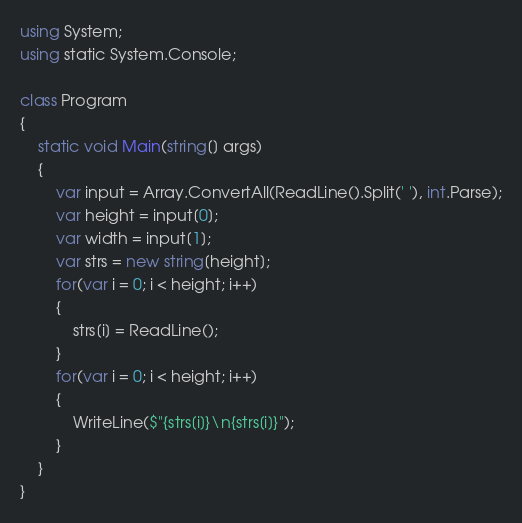Convert code to text. <code><loc_0><loc_0><loc_500><loc_500><_C#_>using System;
using static System.Console;

class Program
{
    static void Main(string[] args)
    {
        var input = Array.ConvertAll(ReadLine().Split(' '), int.Parse);
        var height = input[0];
        var width = input[1];
        var strs = new string[height];
        for(var i = 0; i < height; i++)
        {
            strs[i] = ReadLine();
        }
        for(var i = 0; i < height; i++)
        {
            WriteLine($"{strs[i]}\n{strs[i]}");
        }
    }
}
</code> 